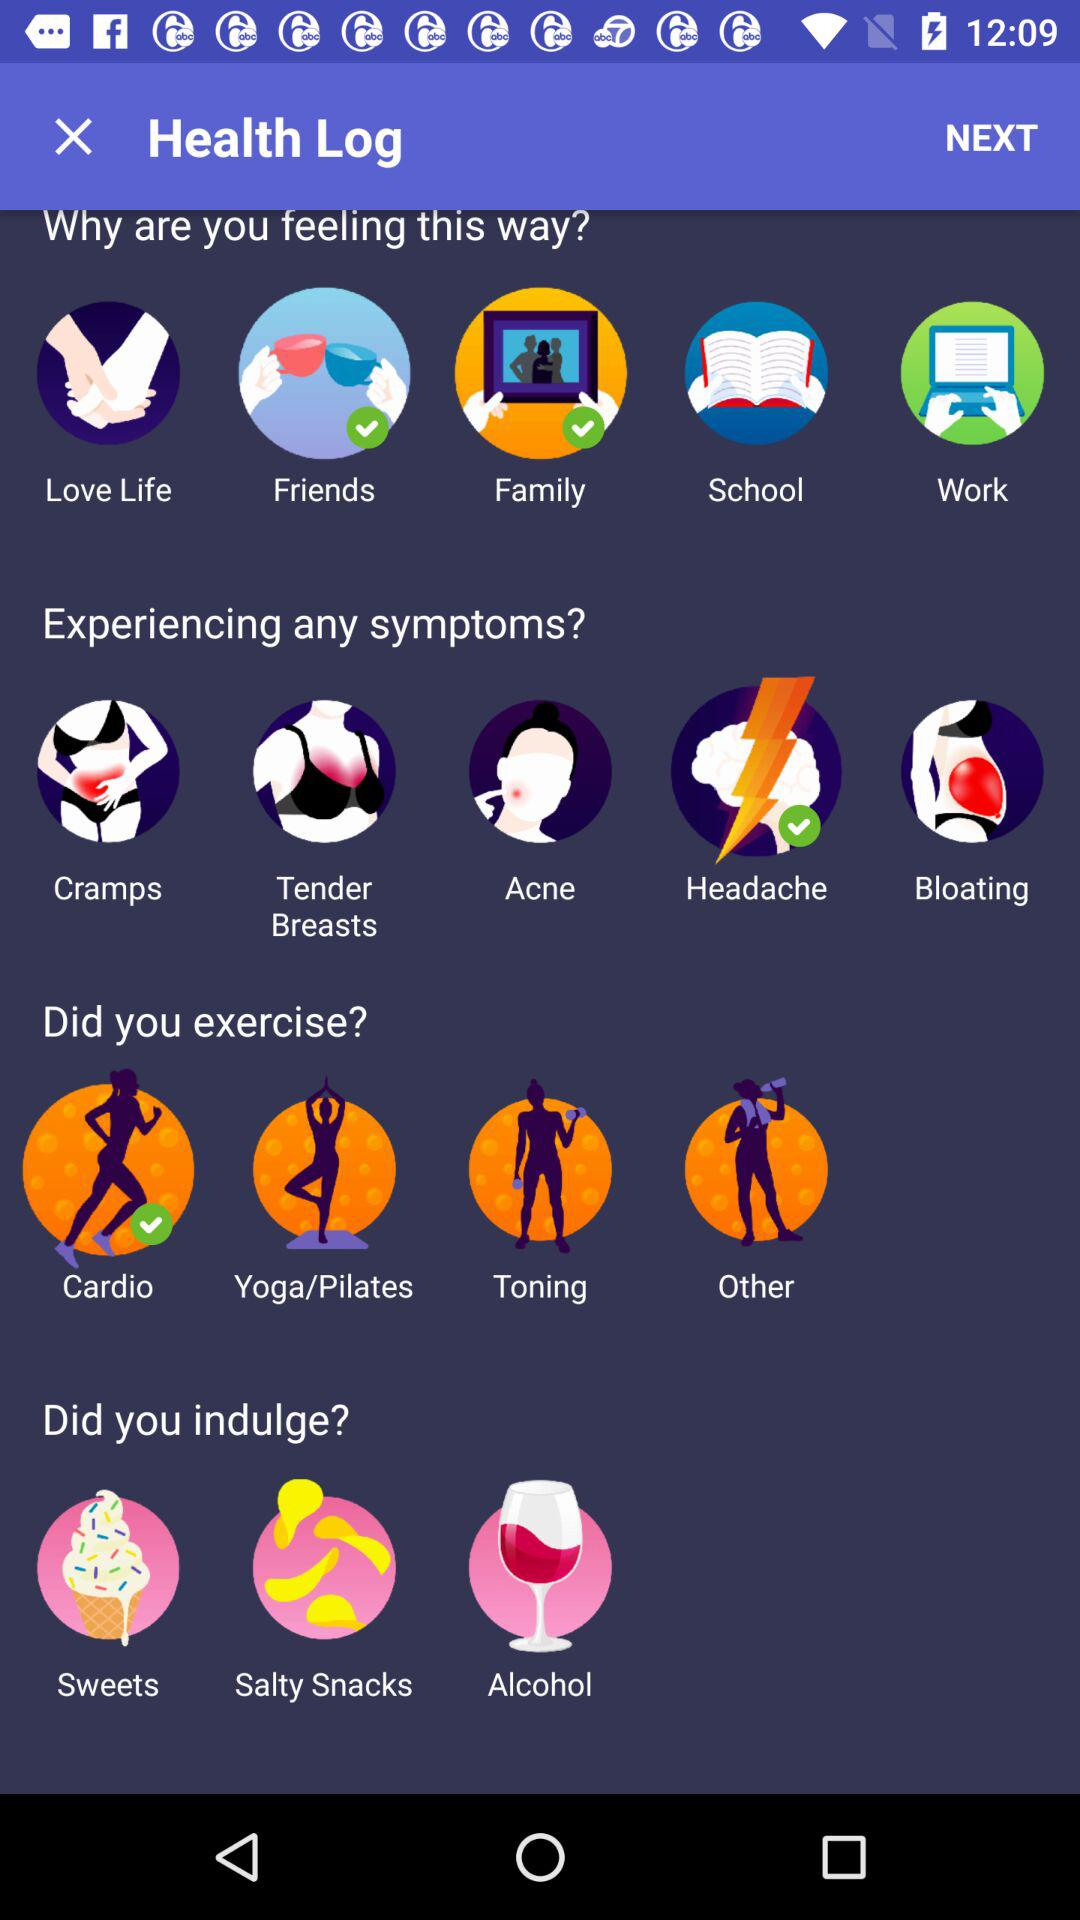Which indulgence is selected?
When the provided information is insufficient, respond with <no answer>. <no answer> 